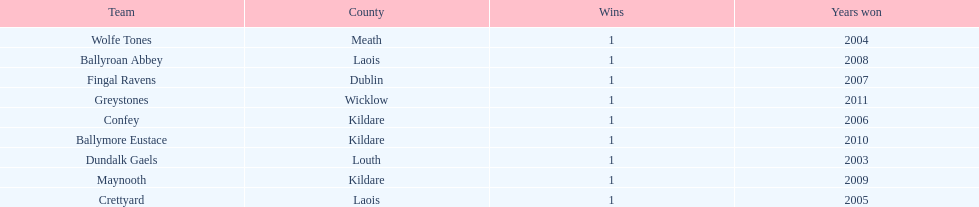How many wins did confey have? 1. 